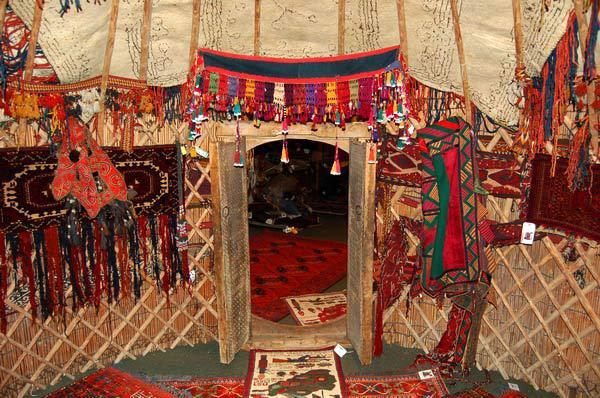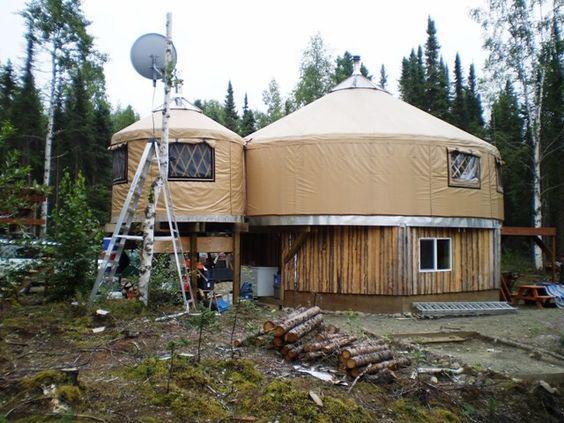The first image is the image on the left, the second image is the image on the right. For the images displayed, is the sentence "Exterior view of a tent with a red door." factually correct? Answer yes or no. No. 